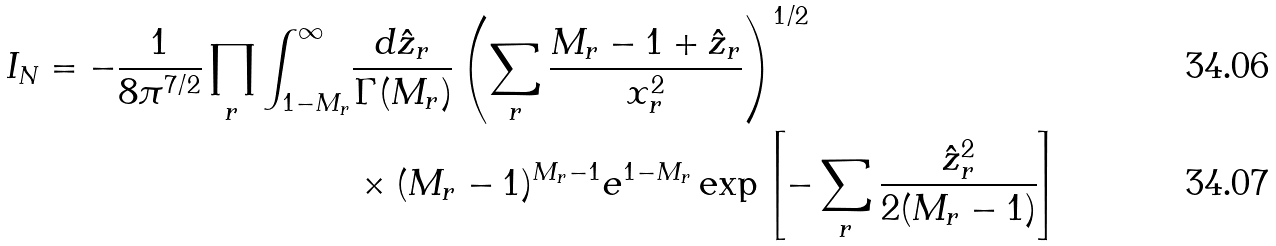Convert formula to latex. <formula><loc_0><loc_0><loc_500><loc_500>I _ { N } = - \frac { 1 } { 8 \pi ^ { 7 / 2 } } \prod _ { r } \int _ { 1 - M _ { r } } ^ { \infty } & \frac { d \hat { z } _ { r } } { \Gamma ( M _ { r } ) } \left ( \sum _ { r } \frac { M _ { r } - 1 + \hat { z } _ { r } } { x _ { r } ^ { 2 } } \right ) ^ { 1 / 2 } \\ & \times ( M _ { r } - 1 ) ^ { M _ { r } - 1 } e ^ { 1 - M _ { r } } \exp \left [ - \sum _ { r } \frac { \hat { z } _ { r } ^ { 2 } } { 2 ( M _ { r } - 1 ) } \right ]</formula> 